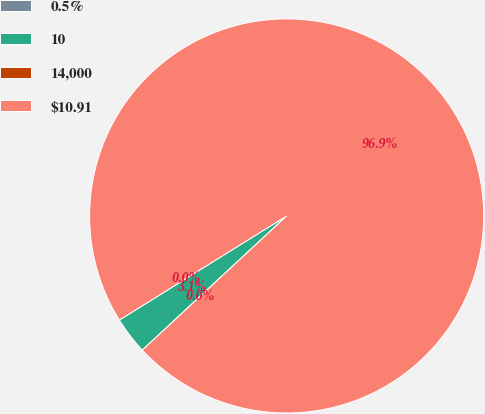Convert chart to OTSL. <chart><loc_0><loc_0><loc_500><loc_500><pie_chart><fcel>0.5%<fcel>10<fcel>14,000<fcel>$10.91<nl><fcel>0.0%<fcel>3.06%<fcel>0.0%<fcel>96.94%<nl></chart> 